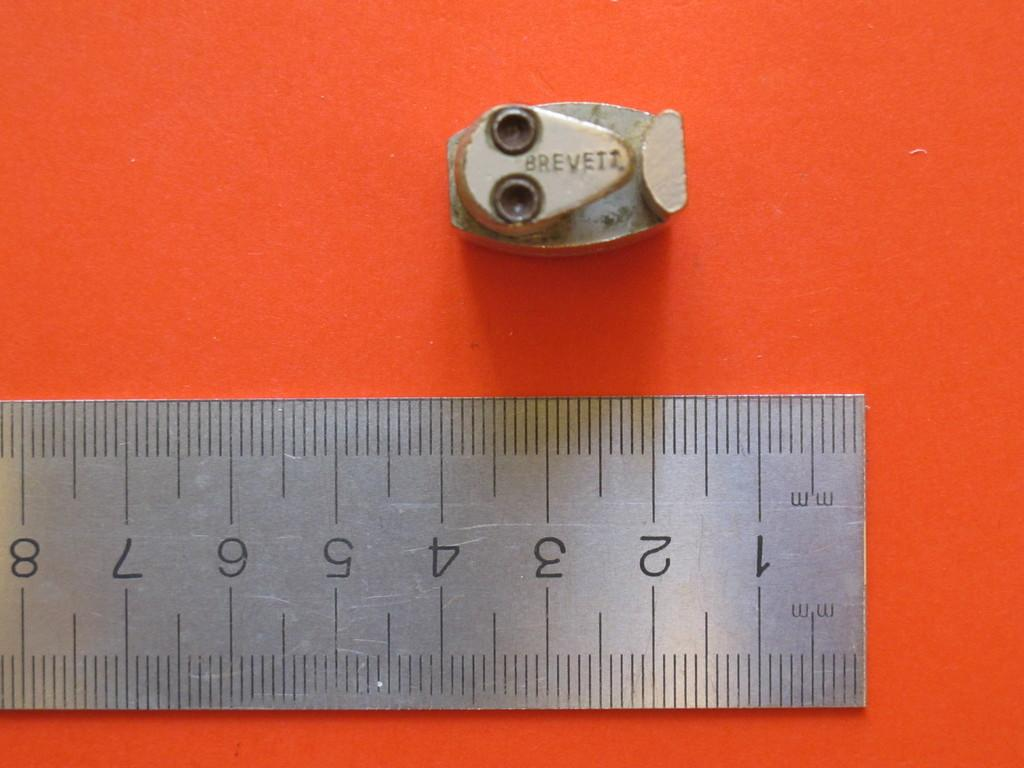<image>
Describe the image concisely. Ruler that has 'mm" on it measuring a tiny object that says Brevett. 